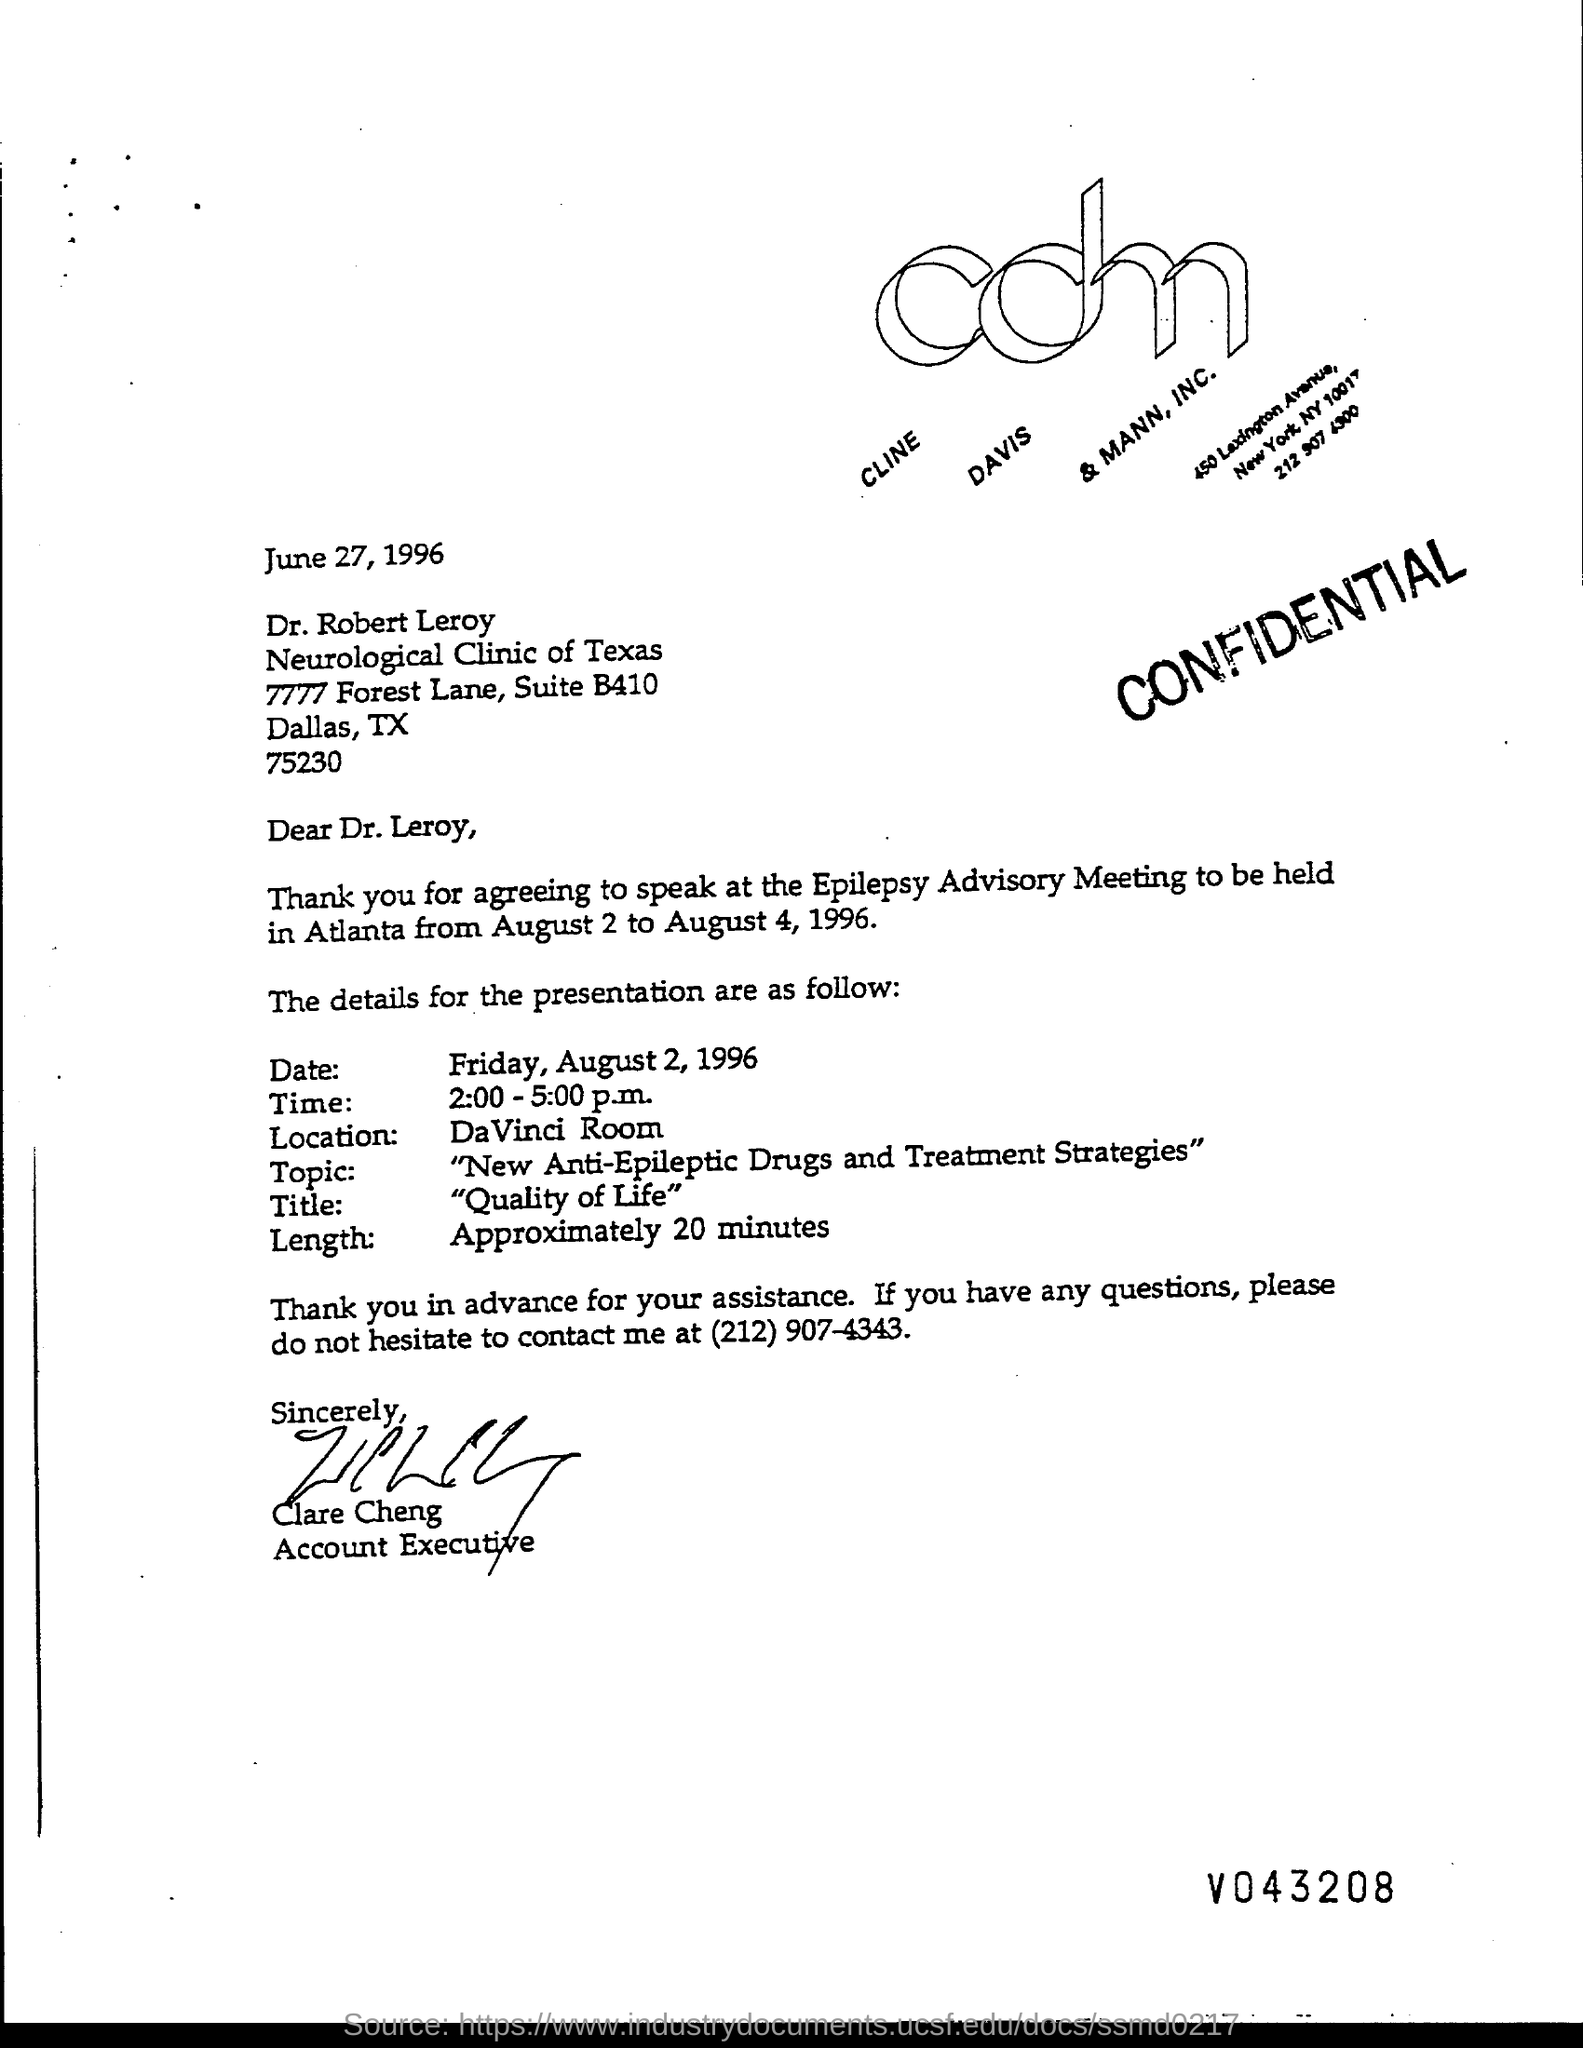What is the issued date of this letter?
Give a very brief answer. JUNE 27, 1996. Who is the sender of this letter?
Provide a short and direct response. CLARE CHENG. What is the designation of Clare Cheng?
Your answer should be compact. ACCOUNT EXECUTIVE. What date is the presentation scheduled as given in the letter?
Your response must be concise. Friday, August 2, 1996. What is the title of the presentation given?
Keep it short and to the point. "QUALITY OF LIFE". 